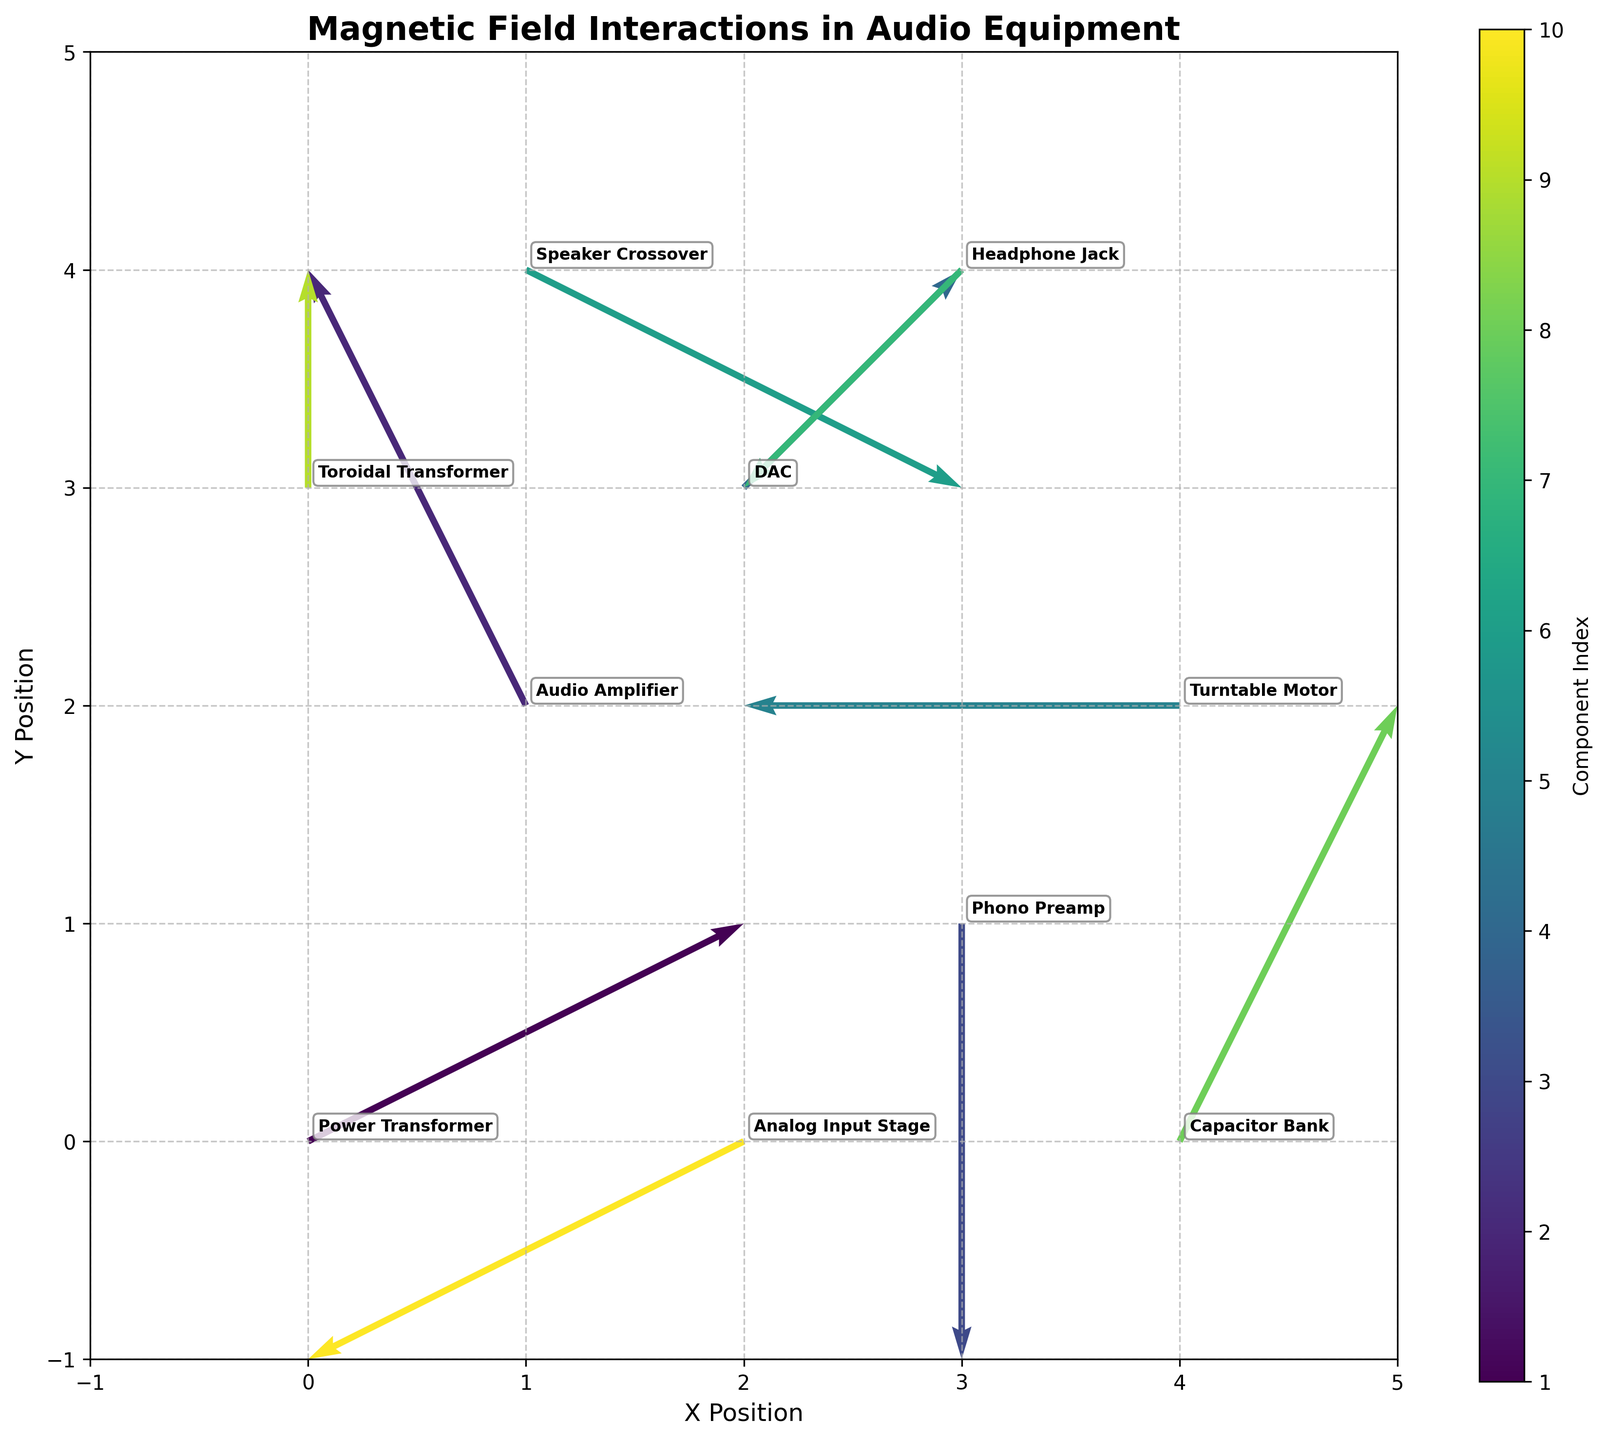What's the title of the plot? The title of the plot is usually found at the top center of the figure, and it provides the general description of the plot. In this case, you should look at the top center of the plot.
Answer: Magnetic Field Interactions in Audio Equipment How many components are there? To determine the number of components, count the number of arrows or annotations present in the figure. Each arrow represents a different component.
Answer: 10 What is the x-coordinate and y-coordinate of the Audio Amplifier? Locate the label "Audio Amplifier" on the plot and find its position by reading the values on the x and y axes where it is located.
Answer: (1, 2) Which component has the largest horizontal magnetic field interaction? The component with the largest horizontal interaction will have the longest arrow in the x-direction. By observing, you can see which component's arrow stretches the most horizontally.
Answer: Power Transformer How many components have an upward magnetic field interaction? Look for arrows that have a positive y-component (pointing upwards) and count these arrows to find how many components have upward interactions.
Answer: 4 Which component is affected by an equal amount of horizontal and vertical magnetic field interaction? Look for the component whose arrow's u and v values are equal. This means the arrow should have the same length horizontally and vertically.
Answer: DAC What components experience a negative magnetic field interaction in both x and y directions? Find the arrows pointing towards the lower left (both x and y directions negative). Identify the components attached to these arrows.
Answer: Analog Input Stage, Headphone Jack Identify the component with the least vertical magnetic field interaction. Find the arrow with the shortest length in the y-direction (vertical). This component has the least vertical magnetic field interaction.
Answer: Turntable Motor Do any components have no horizontal interaction? If yes, name them. Look for arrows where u = 0, meaning there is no horizontal interaction. Identify these components.
Answer: Phono Preamp, Toroidal Transformer Which component is nearest to the origin (0,0)? Measure the distance from the origin to each component's coordinates and find the smallest distance. This can be calculated using the distance formula sqrt((x-0)^2 + (y-0)^2).
Answer: Power Transformer 